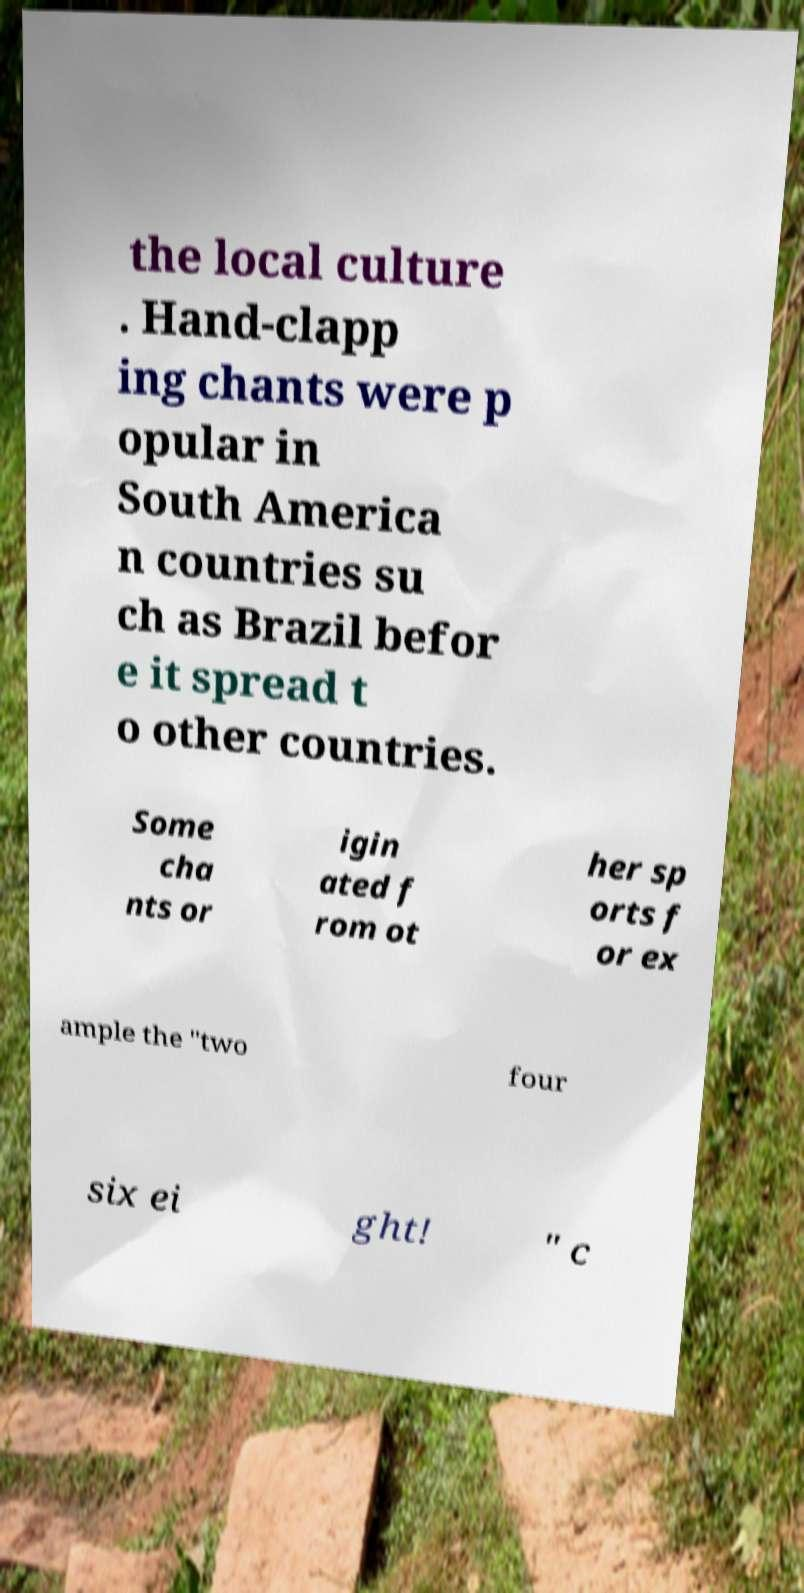Could you extract and type out the text from this image? the local culture . Hand-clapp ing chants were p opular in South America n countries su ch as Brazil befor e it spread t o other countries. Some cha nts or igin ated f rom ot her sp orts f or ex ample the "two four six ei ght! " c 